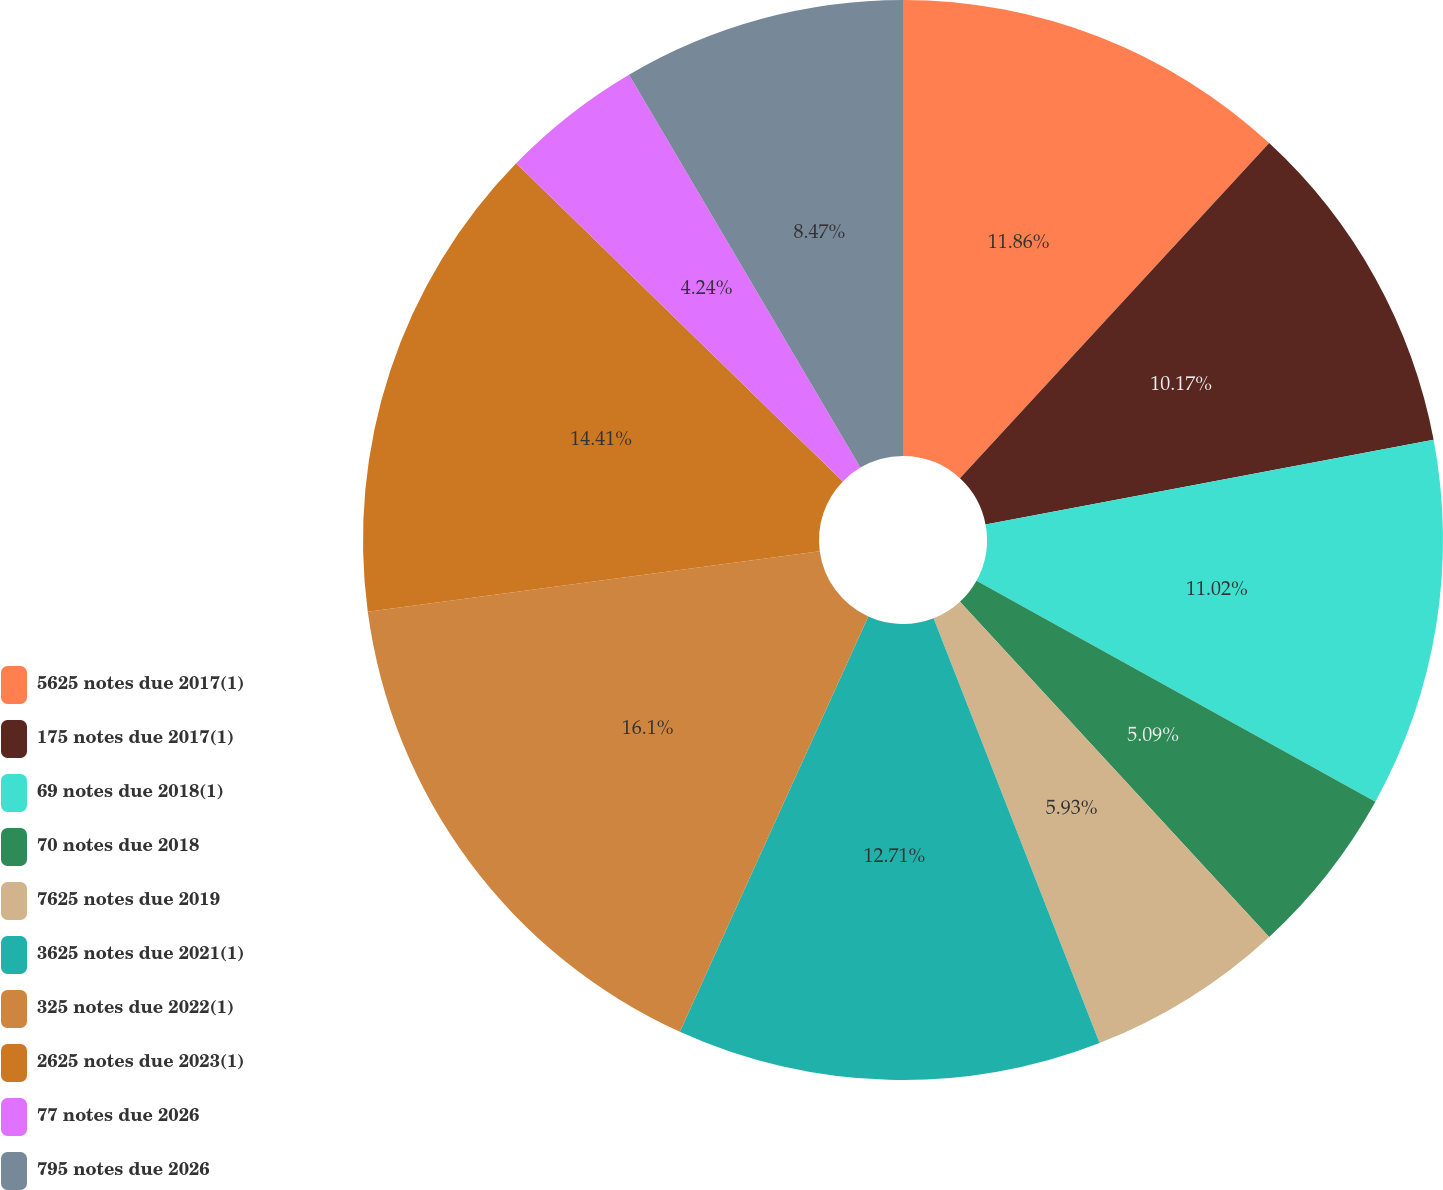Convert chart. <chart><loc_0><loc_0><loc_500><loc_500><pie_chart><fcel>5625 notes due 2017(1)<fcel>175 notes due 2017(1)<fcel>69 notes due 2018(1)<fcel>70 notes due 2018<fcel>7625 notes due 2019<fcel>3625 notes due 2021(1)<fcel>325 notes due 2022(1)<fcel>2625 notes due 2023(1)<fcel>77 notes due 2026<fcel>795 notes due 2026<nl><fcel>11.86%<fcel>10.17%<fcel>11.02%<fcel>5.09%<fcel>5.93%<fcel>12.71%<fcel>16.1%<fcel>14.41%<fcel>4.24%<fcel>8.47%<nl></chart> 